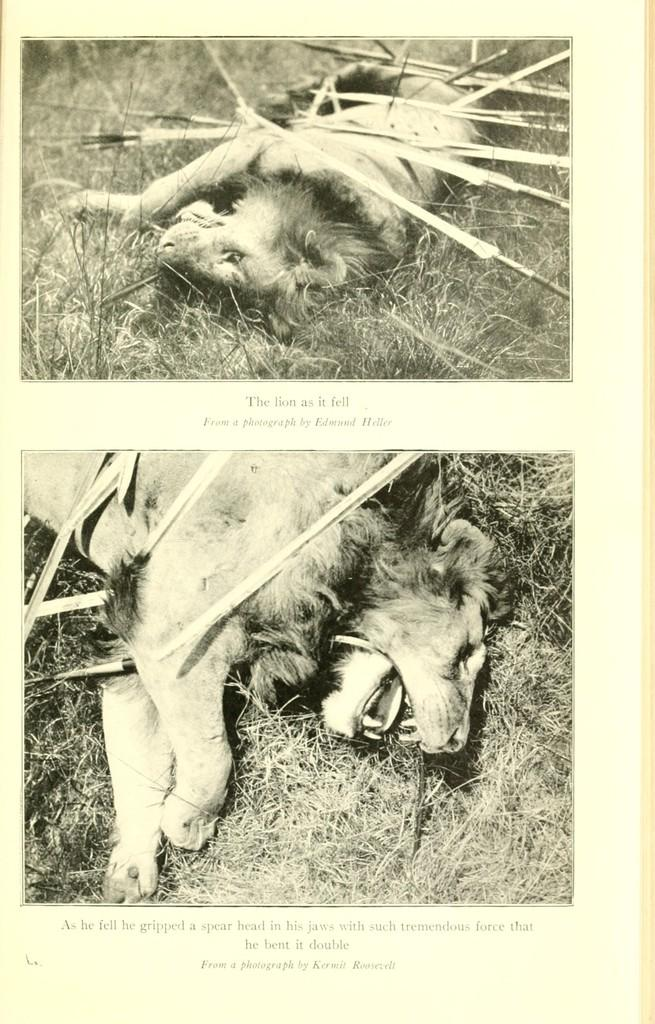What is featured on the poster in the image? The poster contains animals, grass, and text. Can you describe the animals depicted on the poster? The provided facts do not specify the type of animals on the poster. What else is present on the poster besides the animals and grass? The poster contains text. What is the purpose of the wheel in the image? There is no wheel present in the image. 